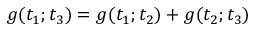<formula> <loc_0><loc_0><loc_500><loc_500>g ( t _ { 1 } ; t _ { 3 } ) = g ( t _ { 1 } ; t _ { 2 } ) + g ( t _ { 2 } ; t _ { 3 } )</formula> 